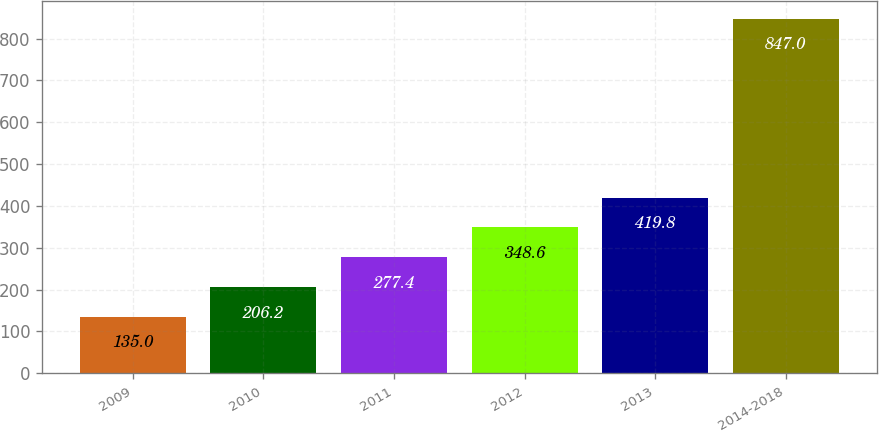<chart> <loc_0><loc_0><loc_500><loc_500><bar_chart><fcel>2009<fcel>2010<fcel>2011<fcel>2012<fcel>2013<fcel>2014-2018<nl><fcel>135<fcel>206.2<fcel>277.4<fcel>348.6<fcel>419.8<fcel>847<nl></chart> 